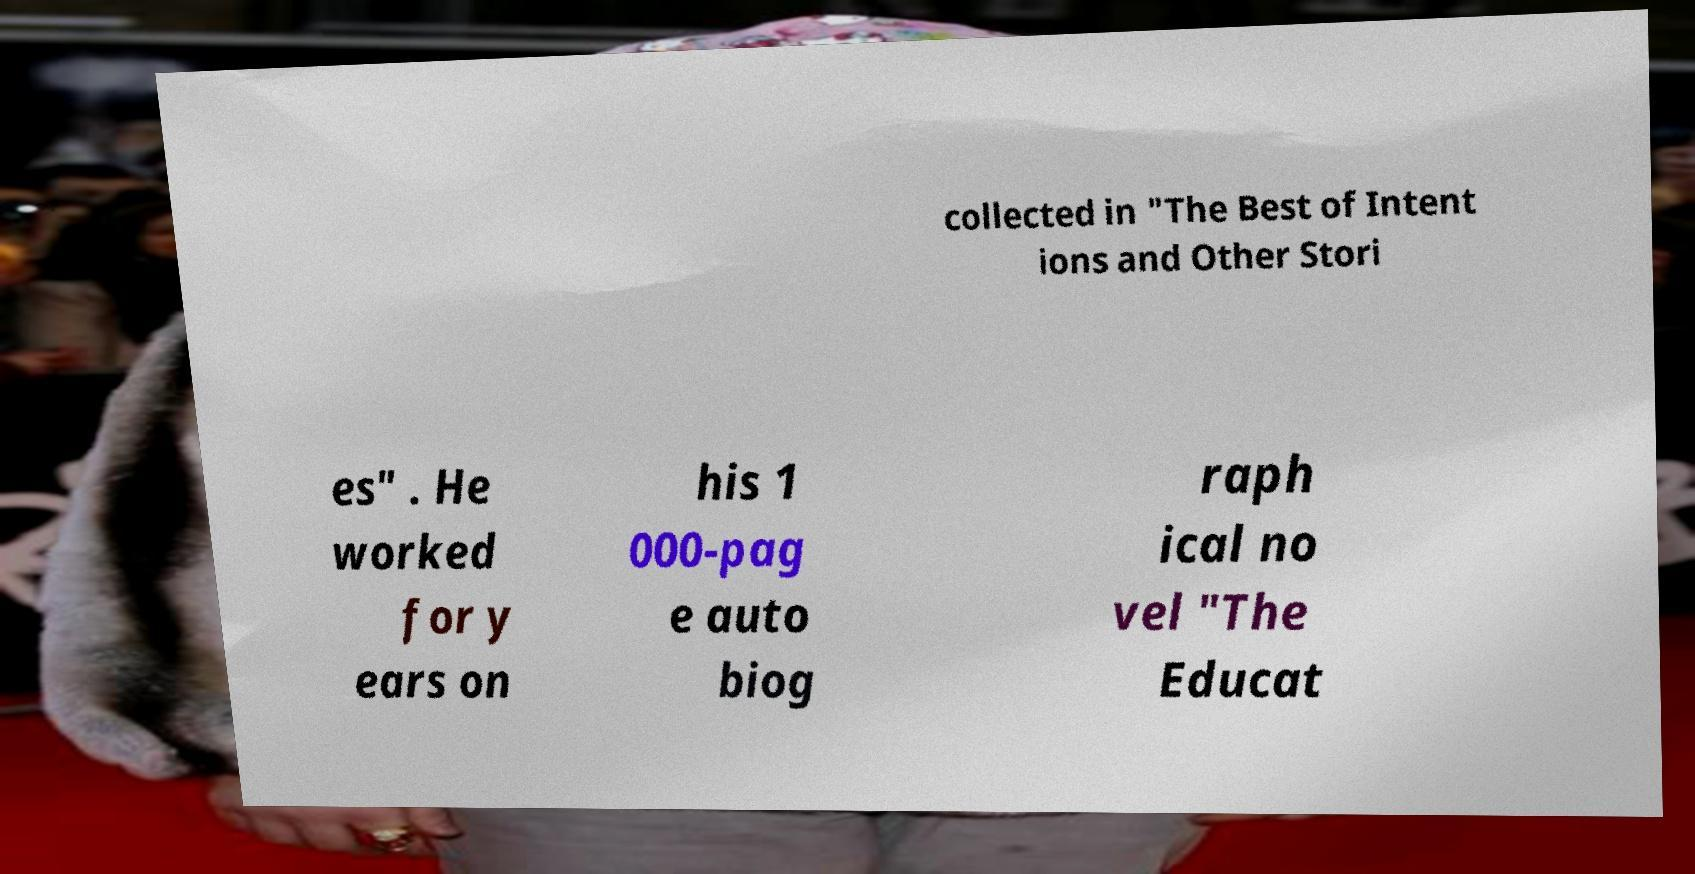Please identify and transcribe the text found in this image. collected in "The Best of Intent ions and Other Stori es" . He worked for y ears on his 1 000-pag e auto biog raph ical no vel "The Educat 